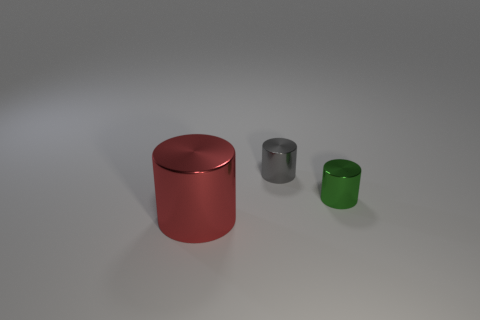Is there any other thing that has the same size as the red metallic cylinder?
Provide a short and direct response. No. There is a object that is in front of the green cylinder; does it have the same shape as the small green object?
Provide a succinct answer. Yes. How many objects are either small gray metal objects or metal things in front of the gray cylinder?
Provide a succinct answer. 3. Is the number of shiny things on the right side of the large shiny cylinder greater than the number of gray rubber objects?
Ensure brevity in your answer.  Yes. Are there an equal number of big metal objects that are in front of the red cylinder and cylinders that are behind the tiny green metal cylinder?
Ensure brevity in your answer.  No. There is a tiny metal object to the right of the gray cylinder; are there any red cylinders behind it?
Give a very brief answer. No. What is the shape of the gray object?
Your response must be concise. Cylinder. There is a metal object that is to the right of the small metal thing that is behind the green metallic object; what size is it?
Give a very brief answer. Small. There is a shiny thing that is in front of the green shiny cylinder; what is its size?
Ensure brevity in your answer.  Large. Is the number of big metallic cylinders that are in front of the large metal thing less than the number of green cylinders right of the green cylinder?
Your response must be concise. No. 